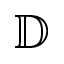<formula> <loc_0><loc_0><loc_500><loc_500>\mathbb { D }</formula> 